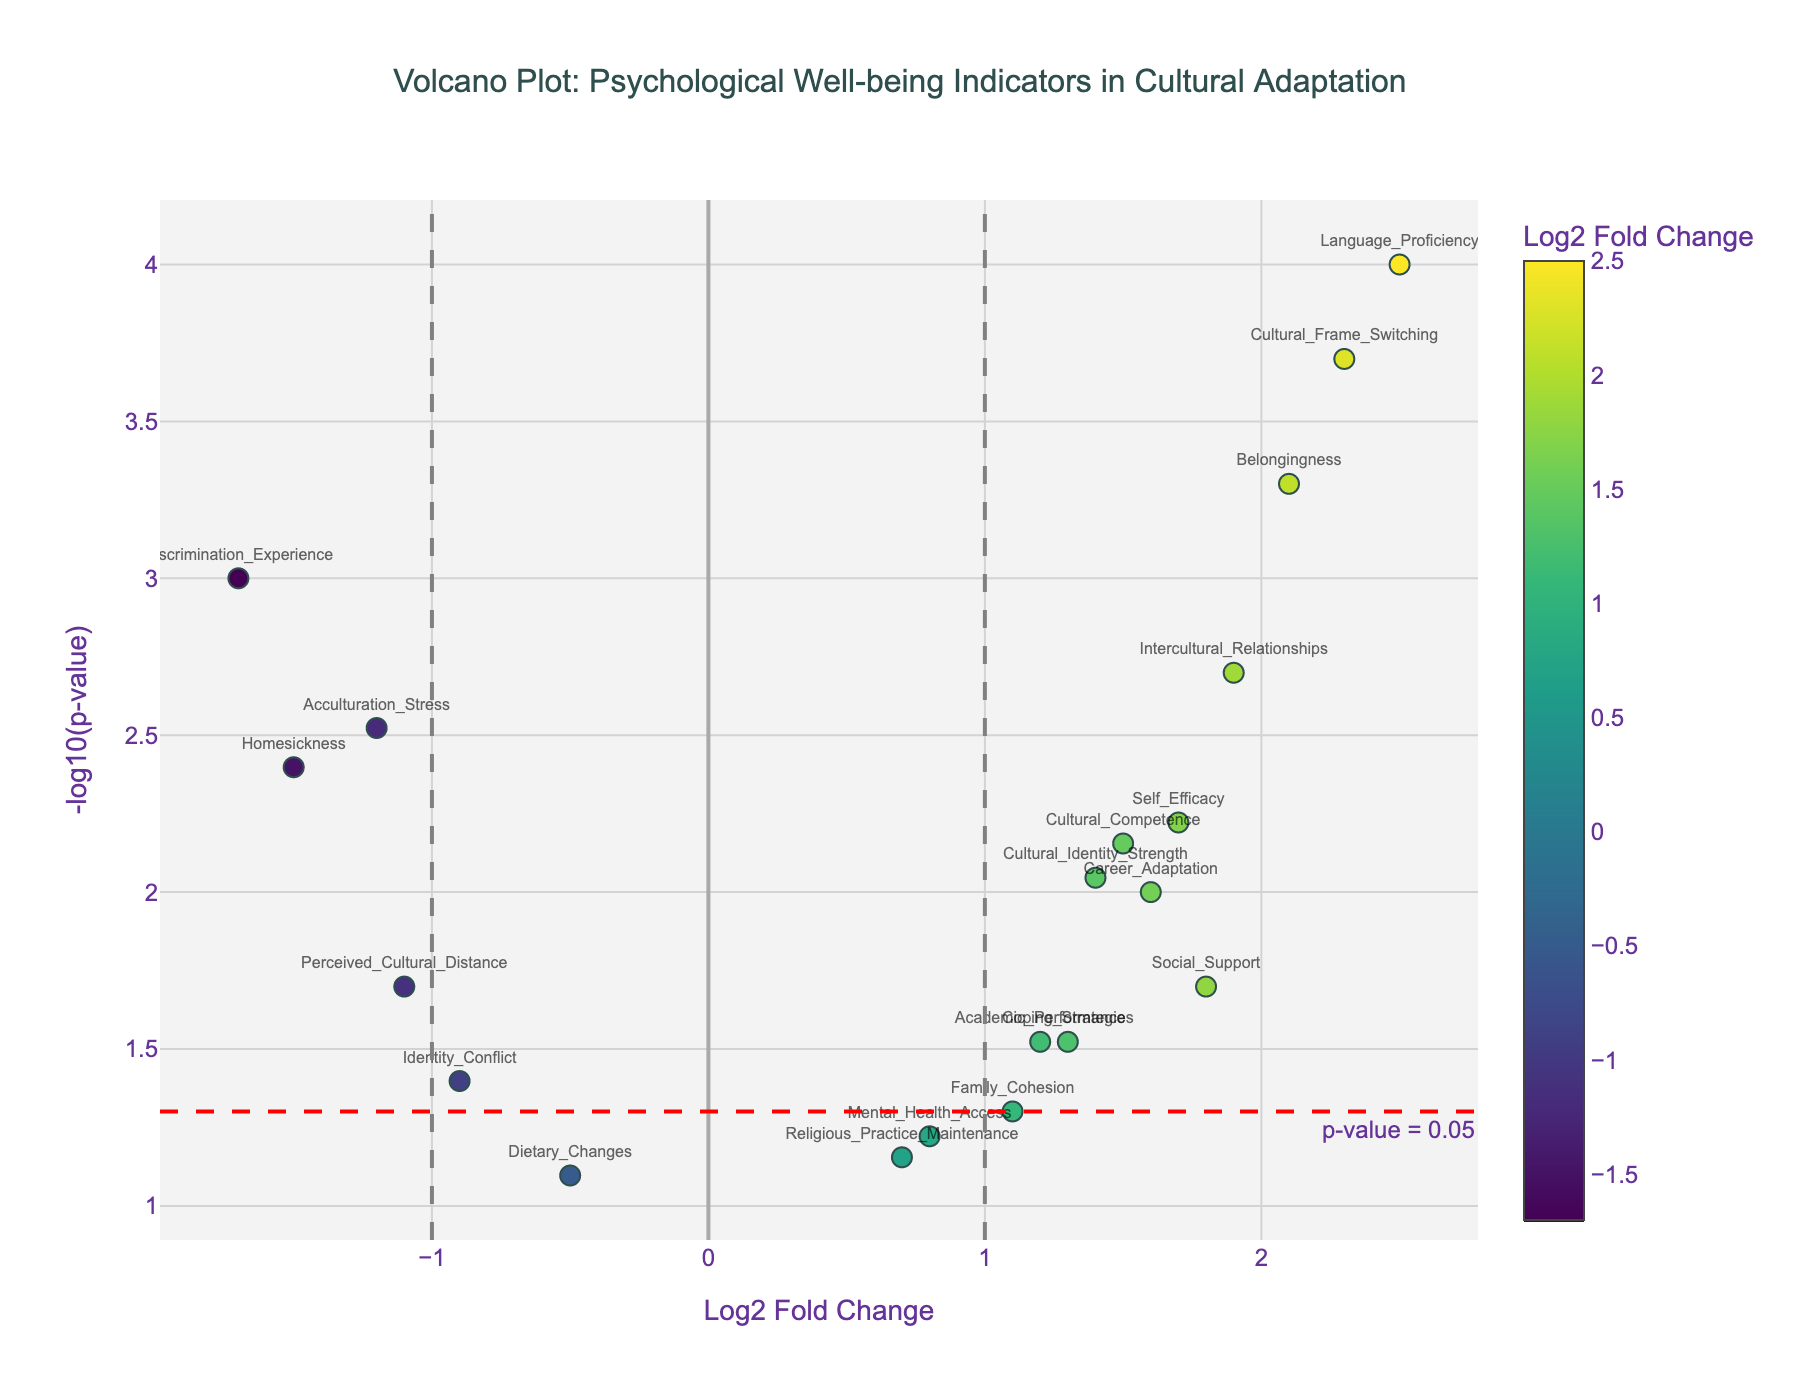How many indicators displayed in the plot have a significant p-value (p < 0.05)? To find this, look for points above the horizontal red threshold line, which represents p = 0.05. Count the number of data points exceeding this threshold.
Answer: 16 Which psychological well-being indicator has the highest Log2 Fold Change? Identify the highest value on the x-axis, which represents Log2 Fold Change, and look at the corresponding data point.
Answer: Language_Proficiency Which indicator appears closest to the threshold for significance with a p-value approximating 0.05? Find the data point nearest to the horizontal red line (p = 0.05), which signifies marginal significance.
Answer: Family_Cohesion Is the Log2 Fold Change of "Discrimination_Experience" greater or less than zero? "Discrimination_Experience" is located to the left of the y-axis, where Log2 Fold Change values are negative.
Answer: Less than zero Of "Acculturation_Stress" and "Homesickness", which has a lower p-value? Compare the vertical positions of both data points; the one located higher has the lower p-value.
Answer: Homesickness What is the p-value threshold represented by the red dashed horizontal line? The threshold value can be read from the annotation near the red line, which displays "p-value = 0.05".
Answer: 0.05 Which indicator has the lowest Log2 Fold Change? Identify the leftmost data point on the x-axis, which represents the most negative Log2 Fold Change.
Answer: Discrimination_Experience How many indicators have a Log2 Fold Change greater than 1 and significant p-value (p < 0.05)? Identify data points located right of the vertical line at Log2 Fold Change = 1 and above the horizontal red line for p = 0.05. Count these data points.
Answer: 7 Among "Social_Support", "Identity_Conflict", and "Coping_Strategies", which indicator has the smallest Log2 Fold Change? Compare their positions on the x-axis. "Identity_Conflict" is positioned the farthest to the left among these three.
Answer: Identity_Conflict What is the p-value for the indicator "Cultural_Frame_Switching"? Locate "Cultural_Frame_Switching" on the plot and check its position on the y-axis. Its -log10(p-value) can be used to calculate the p-value using the formula p-value = 10^(-y).
Answer: 0.0002 